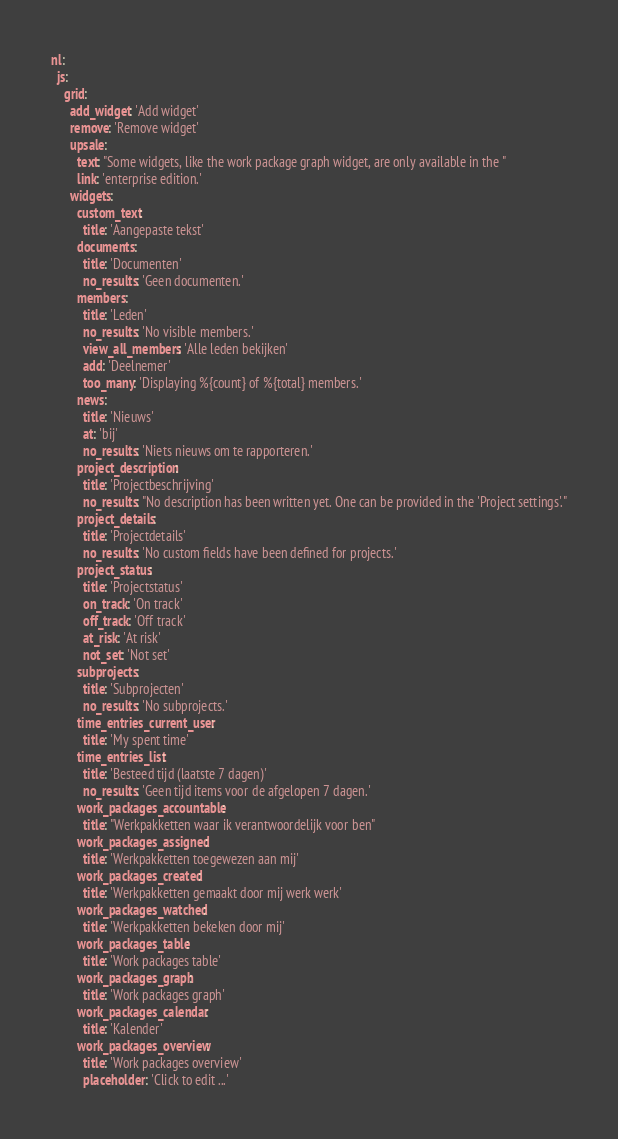Convert code to text. <code><loc_0><loc_0><loc_500><loc_500><_YAML_>nl:
  js:
    grid:
      add_widget: 'Add widget'
      remove: 'Remove widget'
      upsale:
        text: "Some widgets, like the work package graph widget, are only available in the "
        link: 'enterprise edition.'
      widgets:
        custom_text:
          title: 'Aangepaste tekst'
        documents:
          title: 'Documenten'
          no_results: 'Geen documenten.'
        members:
          title: 'Leden'
          no_results: 'No visible members.'
          view_all_members: 'Alle leden bekijken'
          add: 'Deelnemer'
          too_many: 'Displaying %{count} of %{total} members.'
        news:
          title: 'Nieuws'
          at: 'bij'
          no_results: 'Niets nieuws om te rapporteren.'
        project_description:
          title: 'Projectbeschrijving'
          no_results: "No description has been written yet. One can be provided in the 'Project settings'."
        project_details:
          title: 'Projectdetails'
          no_results: 'No custom fields have been defined for projects.'
        project_status:
          title: 'Projectstatus'
          on_track: 'On track'
          off_track: 'Off track'
          at_risk: 'At risk'
          not_set: 'Not set'
        subprojects:
          title: 'Subprojecten'
          no_results: 'No subprojects.'
        time_entries_current_user:
          title: 'My spent time'
        time_entries_list:
          title: 'Besteed tijd (laatste 7 dagen)'
          no_results: 'Geen tijd items voor de afgelopen 7 dagen.'
        work_packages_accountable:
          title: "Werkpakketten waar ik verantwoordelijk voor ben"
        work_packages_assigned:
          title: 'Werkpakketten toegewezen aan mij'
        work_packages_created:
          title: 'Werkpakketten gemaakt door mij werk werk'
        work_packages_watched:
          title: 'Werkpakketten bekeken door mij'
        work_packages_table:
          title: 'Work packages table'
        work_packages_graph:
          title: 'Work packages graph'
        work_packages_calendar:
          title: 'Kalender'
        work_packages_overview:
          title: 'Work packages overview'
          placeholder: 'Click to edit ...'
</code> 